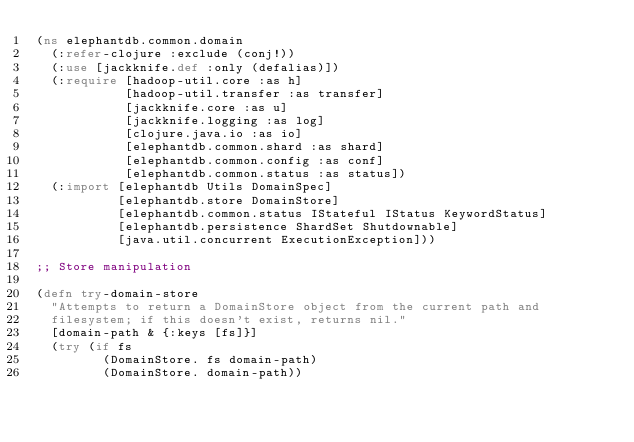Convert code to text. <code><loc_0><loc_0><loc_500><loc_500><_Clojure_>(ns elephantdb.common.domain
  (:refer-clojure :exclude (conj!))
  (:use [jackknife.def :only (defalias)])
  (:require [hadoop-util.core :as h]
            [hadoop-util.transfer :as transfer]
            [jackknife.core :as u]
            [jackknife.logging :as log]
            [clojure.java.io :as io]
            [elephantdb.common.shard :as shard]
            [elephantdb.common.config :as conf]
            [elephantdb.common.status :as status])
  (:import [elephantdb Utils DomainSpec]
           [elephantdb.store DomainStore]
           [elephantdb.common.status IStateful IStatus KeywordStatus]
           [elephantdb.persistence ShardSet Shutdownable]
           [java.util.concurrent ExecutionException]))

;; Store manipulation

(defn try-domain-store
  "Attempts to return a DomainStore object from the current path and
  filesystem; if this doesn't exist, returns nil."
  [domain-path & {:keys [fs]}]
  (try (if fs
         (DomainStore. fs domain-path)
         (DomainStore. domain-path))</code> 